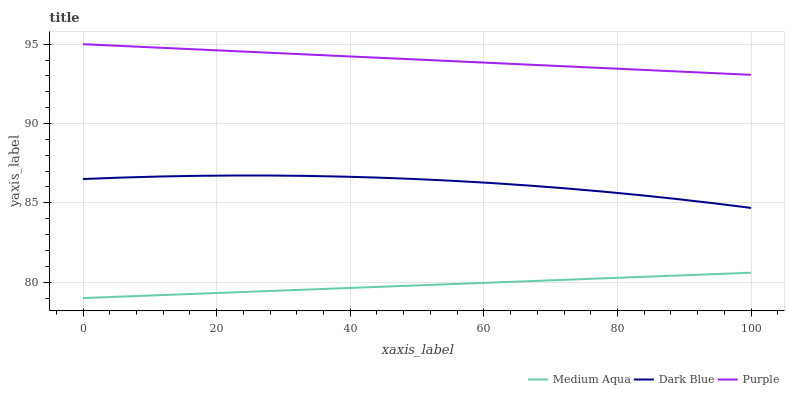Does Medium Aqua have the minimum area under the curve?
Answer yes or no. Yes. Does Purple have the maximum area under the curve?
Answer yes or no. Yes. Does Dark Blue have the minimum area under the curve?
Answer yes or no. No. Does Dark Blue have the maximum area under the curve?
Answer yes or no. No. Is Purple the smoothest?
Answer yes or no. Yes. Is Dark Blue the roughest?
Answer yes or no. Yes. Is Medium Aqua the smoothest?
Answer yes or no. No. Is Medium Aqua the roughest?
Answer yes or no. No. Does Medium Aqua have the lowest value?
Answer yes or no. Yes. Does Dark Blue have the lowest value?
Answer yes or no. No. Does Purple have the highest value?
Answer yes or no. Yes. Does Dark Blue have the highest value?
Answer yes or no. No. Is Medium Aqua less than Dark Blue?
Answer yes or no. Yes. Is Dark Blue greater than Medium Aqua?
Answer yes or no. Yes. Does Medium Aqua intersect Dark Blue?
Answer yes or no. No. 